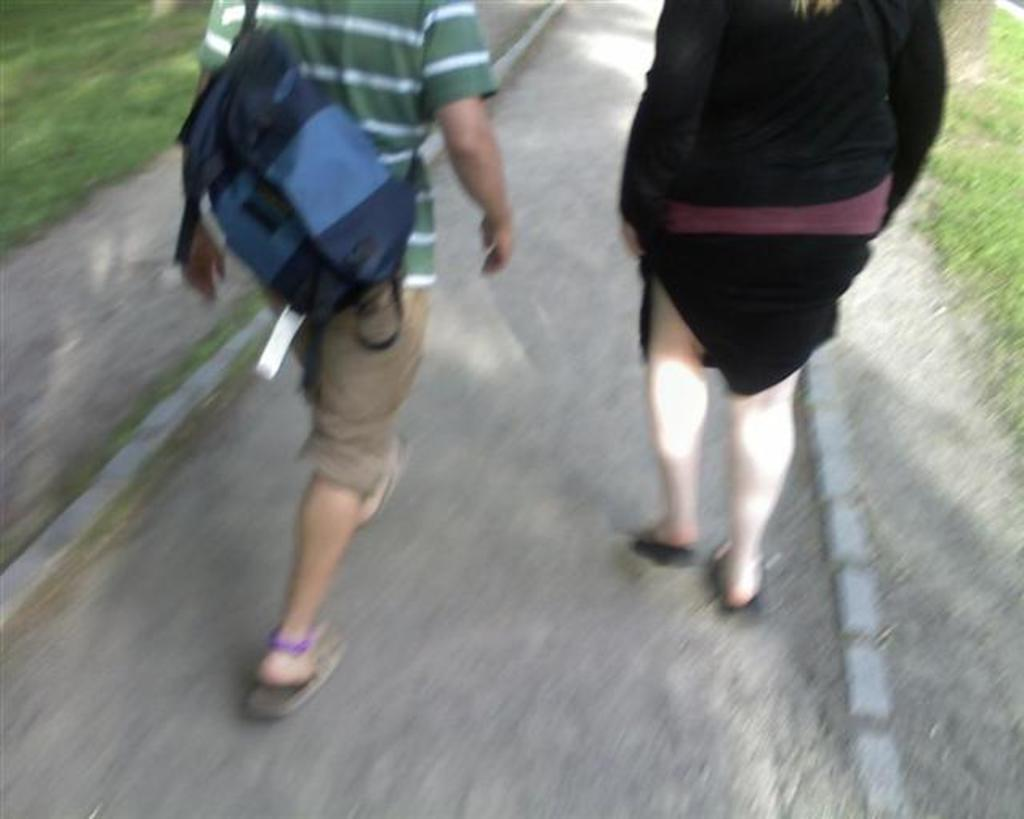What is located at the bottom portion of the image? There is a road at the bottom portion of the image. What type of vegetation can be seen in the image? Green grass is visible in the image. What are the people in the image doing? People are walking on the road in the image. Can you describe the man in the image? There is a man wearing a bag in the image. What type of power can be seen flowing through the grass in the image? There is no power or electricity visible in the image; it only shows a road, green grass, people walking, and a man wearing a bag. 